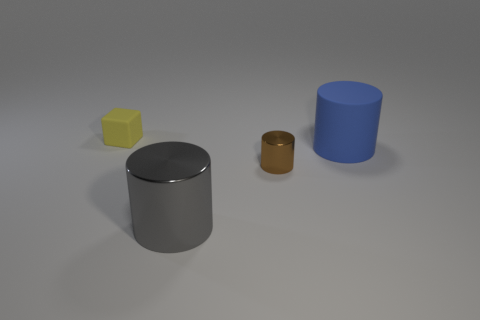There is a object that is both on the left side of the brown thing and behind the large shiny thing; what color is it?
Provide a short and direct response. Yellow. There is a rubber thing that is to the right of the yellow cube; is its size the same as the matte block?
Offer a terse response. No. Are there more large objects that are behind the big metal object than big cubes?
Ensure brevity in your answer.  Yes. Do the gray shiny object and the large blue matte thing have the same shape?
Provide a short and direct response. Yes. What is the size of the yellow object?
Your response must be concise. Small. Are there more gray metal things in front of the blue rubber object than small rubber blocks right of the brown metallic object?
Keep it short and to the point. Yes. Are there any blue things in front of the yellow cube?
Provide a short and direct response. Yes. Is there a gray cylinder of the same size as the blue matte cylinder?
Ensure brevity in your answer.  Yes. What is the color of the other cylinder that is made of the same material as the brown cylinder?
Offer a terse response. Gray. What is the material of the tiny yellow thing?
Your answer should be very brief. Rubber. 